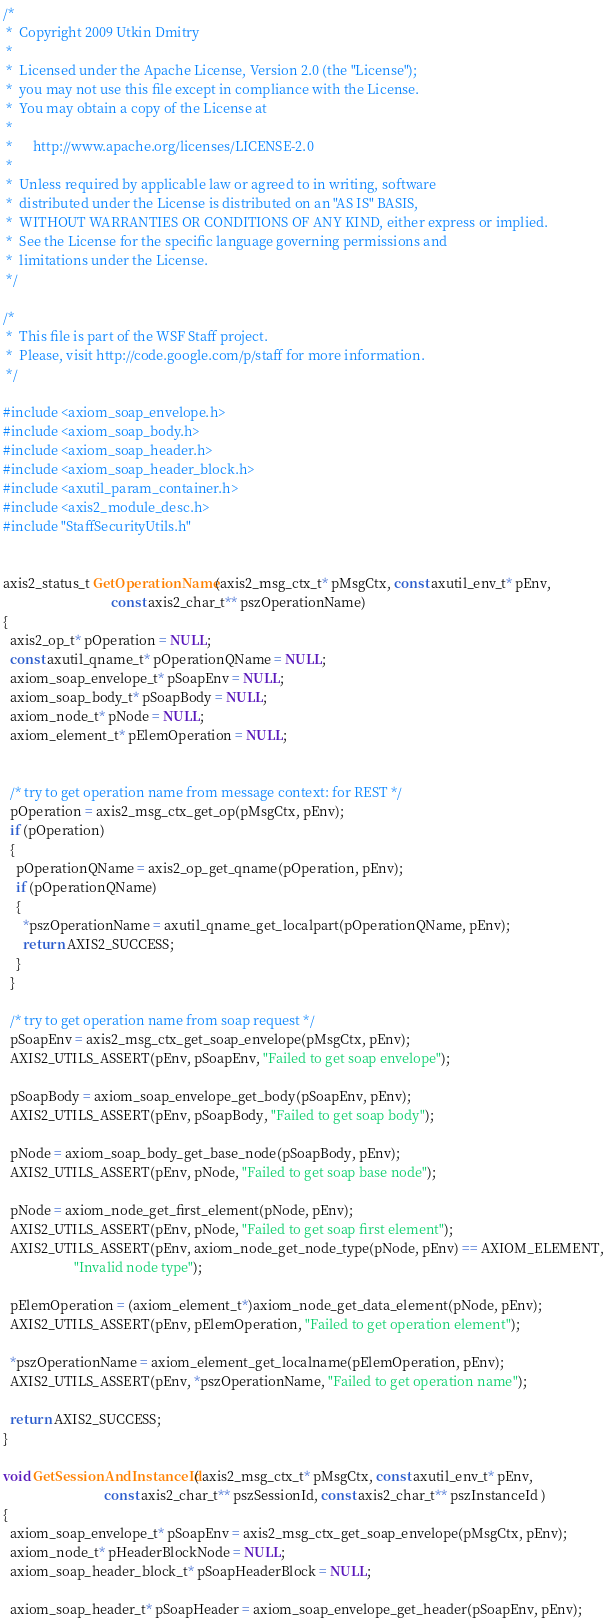<code> <loc_0><loc_0><loc_500><loc_500><_C_>/*
 *  Copyright 2009 Utkin Dmitry
 *
 *  Licensed under the Apache License, Version 2.0 (the "License");
 *  you may not use this file except in compliance with the License.
 *  You may obtain a copy of the License at
 *
 *      http://www.apache.org/licenses/LICENSE-2.0
 *
 *  Unless required by applicable law or agreed to in writing, software
 *  distributed under the License is distributed on an "AS IS" BASIS,
 *  WITHOUT WARRANTIES OR CONDITIONS OF ANY KIND, either express or implied.
 *  See the License for the specific language governing permissions and
 *  limitations under the License.
 */
 
/* 
 *  This file is part of the WSF Staff project.
 *  Please, visit http://code.google.com/p/staff for more information.
 */

#include <axiom_soap_envelope.h>
#include <axiom_soap_body.h>
#include <axiom_soap_header.h>
#include <axiom_soap_header_block.h>
#include <axutil_param_container.h>
#include <axis2_module_desc.h>
#include "StaffSecurityUtils.h"


axis2_status_t GetOperationName(axis2_msg_ctx_t* pMsgCtx, const axutil_env_t* pEnv,
                                const axis2_char_t** pszOperationName)
{
  axis2_op_t* pOperation = NULL;
  const axutil_qname_t* pOperationQName = NULL;
  axiom_soap_envelope_t* pSoapEnv = NULL;
  axiom_soap_body_t* pSoapBody = NULL;
  axiom_node_t* pNode = NULL;
  axiom_element_t* pElemOperation = NULL;


  /* try to get operation name from message context: for REST */
  pOperation = axis2_msg_ctx_get_op(pMsgCtx, pEnv);
  if (pOperation)
  {
    pOperationQName = axis2_op_get_qname(pOperation, pEnv);
    if (pOperationQName)
    {
      *pszOperationName = axutil_qname_get_localpart(pOperationQName, pEnv);
      return AXIS2_SUCCESS;
    }
  }

  /* try to get operation name from soap request */
  pSoapEnv = axis2_msg_ctx_get_soap_envelope(pMsgCtx, pEnv);
  AXIS2_UTILS_ASSERT(pEnv, pSoapEnv, "Failed to get soap envelope");

  pSoapBody = axiom_soap_envelope_get_body(pSoapEnv, pEnv);
  AXIS2_UTILS_ASSERT(pEnv, pSoapBody, "Failed to get soap body");

  pNode = axiom_soap_body_get_base_node(pSoapBody, pEnv);
  AXIS2_UTILS_ASSERT(pEnv, pNode, "Failed to get soap base node");

  pNode = axiom_node_get_first_element(pNode, pEnv);
  AXIS2_UTILS_ASSERT(pEnv, pNode, "Failed to get soap first element");
  AXIS2_UTILS_ASSERT(pEnv, axiom_node_get_node_type(pNode, pEnv) == AXIOM_ELEMENT,
                     "Invalid node type");

  pElemOperation = (axiom_element_t*)axiom_node_get_data_element(pNode, pEnv);
  AXIS2_UTILS_ASSERT(pEnv, pElemOperation, "Failed to get operation element");

  *pszOperationName = axiom_element_get_localname(pElemOperation, pEnv);
  AXIS2_UTILS_ASSERT(pEnv, *pszOperationName, "Failed to get operation name");

  return AXIS2_SUCCESS;
}

void GetSessionAndInstanceId( axis2_msg_ctx_t* pMsgCtx, const axutil_env_t* pEnv,
                              const axis2_char_t** pszSessionId, const axis2_char_t** pszInstanceId )
{
  axiom_soap_envelope_t* pSoapEnv = axis2_msg_ctx_get_soap_envelope(pMsgCtx, pEnv);
  axiom_node_t* pHeaderBlockNode = NULL;  
  axiom_soap_header_block_t* pSoapHeaderBlock = NULL;

  axiom_soap_header_t* pSoapHeader = axiom_soap_envelope_get_header(pSoapEnv, pEnv);</code> 